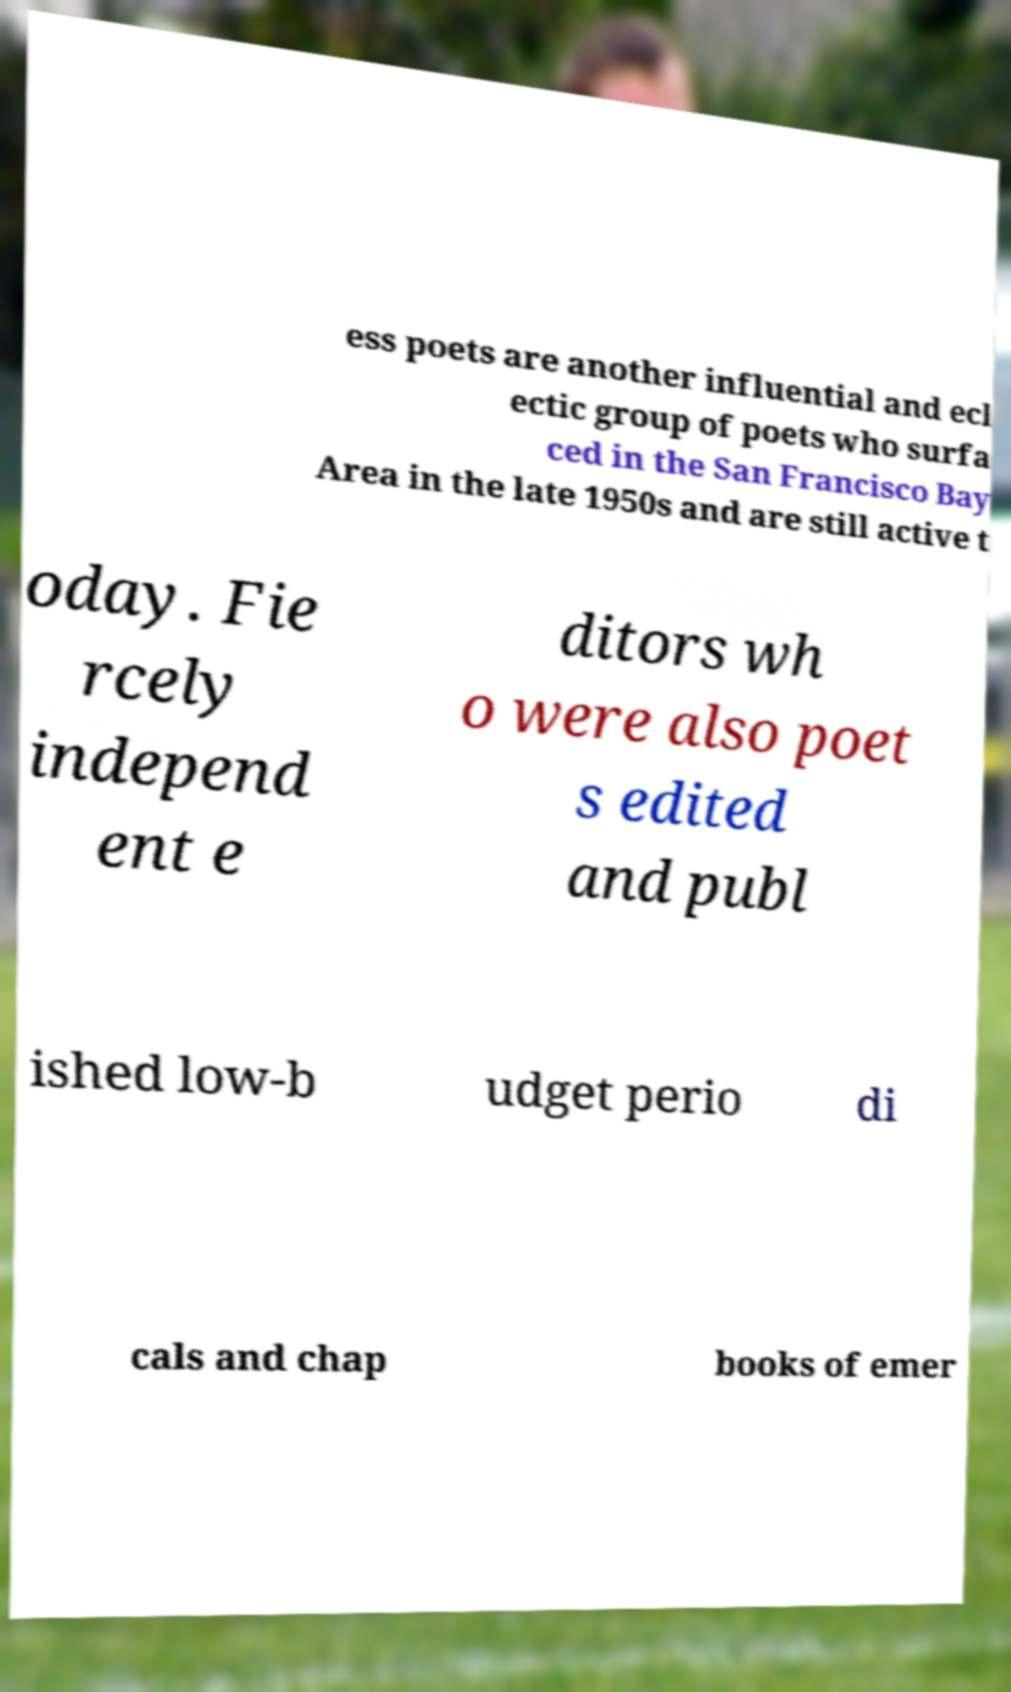I need the written content from this picture converted into text. Can you do that? ess poets are another influential and ecl ectic group of poets who surfa ced in the San Francisco Bay Area in the late 1950s and are still active t oday. Fie rcely independ ent e ditors wh o were also poet s edited and publ ished low-b udget perio di cals and chap books of emer 